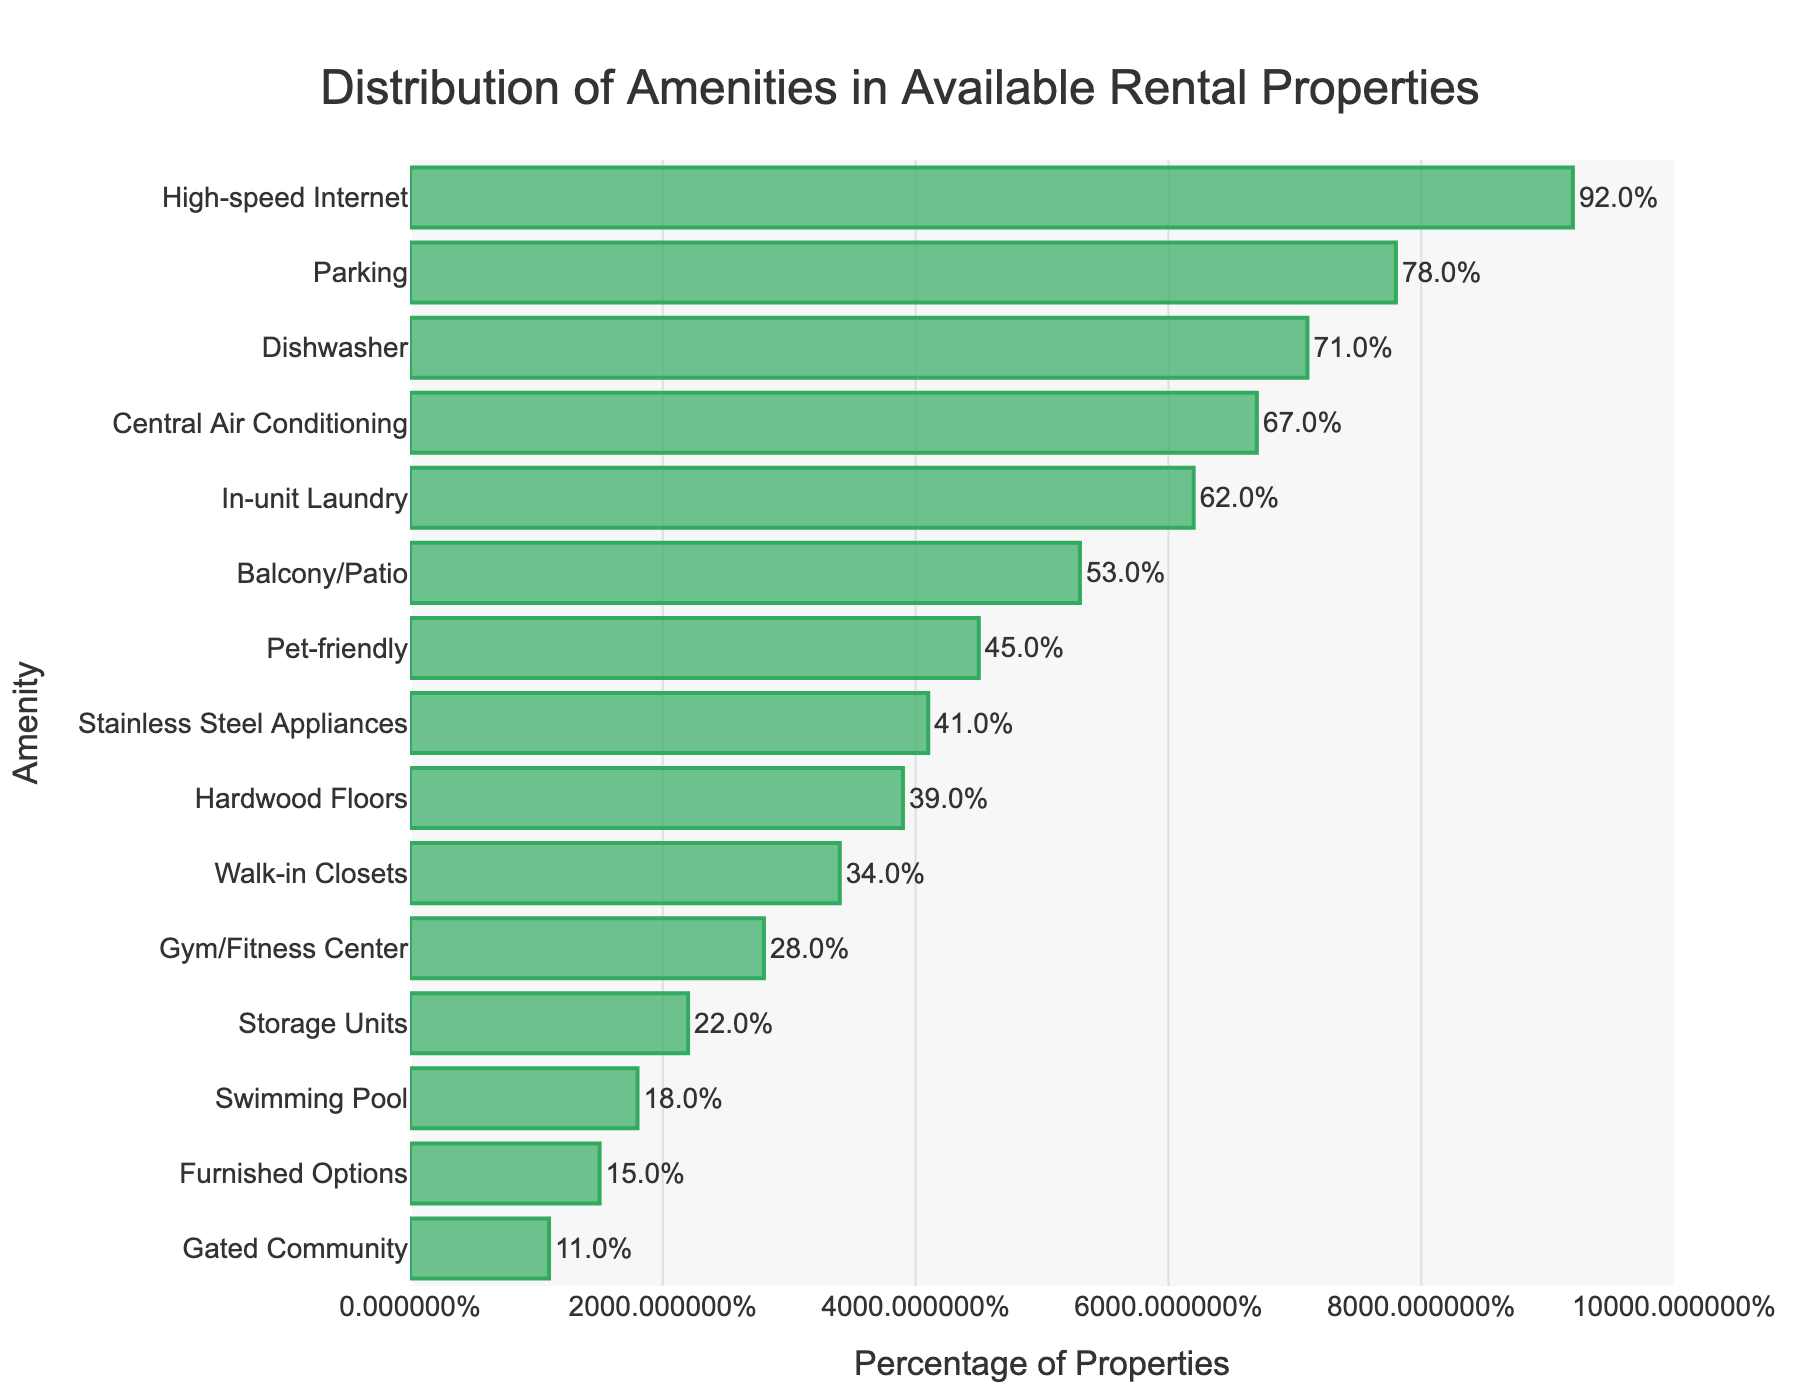What percentage of rental properties have a swimming pool? Locate the bar labeled "Swimming Pool" in the figure and read the value represented by its length.
Answer: 18% Which amenity is available in more properties: hardwood floors or stainless steel appliances? Compare the lengths of the bars labeled "Hardwood Floors" and "Stainless Steel Appliances". The one with the longer bar indicates higher availability.
Answer: Stainless Steel Appliances How much higher is the percentage of properties with a gym/fitness center compared to those with a gated community? Find the percentages for "Gym/Fitness Center" and "Gated Community". Subtract the smaller percentage from the larger one. 28 - 11 = 17
Answer: 17% Which amenity is the most common in the rental properties? Identify the bar with the longest length and read the corresponding amenity label.
Answer: High-speed Internet How many amenities have a percentage of availability less than 30%? Count the bars whose lengths represent values less than 30%.
Answer: 5 Is in-unit laundry more common than a balcony/patio in the rental properties? Compare the lengths of the bars labeled "In-unit Laundry" and "Balcony/Patio". The longer bar indicates higher availability.
Answer: Yes What is the total percentage of properties that offer either a gym/fitness center, swimming pool, or gated community? Locate and sum the percentages of the bars for "Gym/Fitness Center", "Swimming Pool", and "Gated Community". 28 + 18 + 11 = 57
Answer: 57% Do more than 50% of rental properties have central air conditioning? Locate the bar labeled "Central Air Conditioning" and check if the percentage is greater than 50%.
Answer: Yes Among the listed amenities, which two are the least common? Identify the two bars with the shortest lengths and read their corresponding amenity labels.
Answer: Gated Community and Furnished Options 